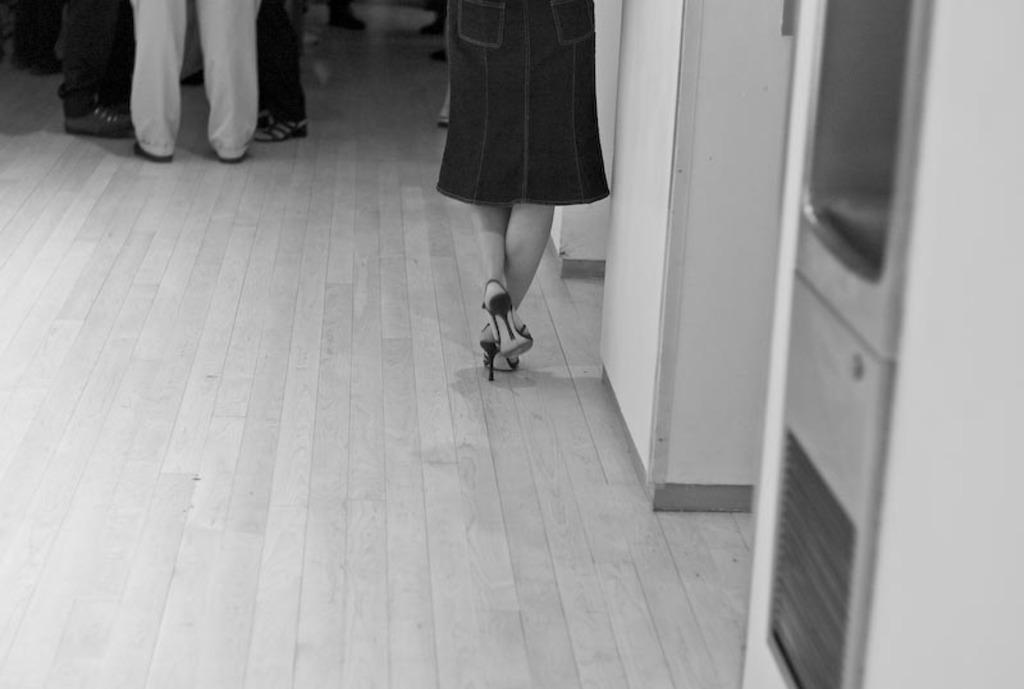How many people are in the image? There is a group of persons in the image, but the exact number cannot be determined from the provided facts. What is located on the right side of the image? There is a wall on the right side of the image. What is the color of the wall? The wall is white in color. What other object can be seen in the image? There is a cupboard in the image. What type of pain is the person in the image experiencing? There is no indication of pain or any person's emotional state in the image. What is being served for lunch in the image? There is no mention of lunch or any food items in the image. 